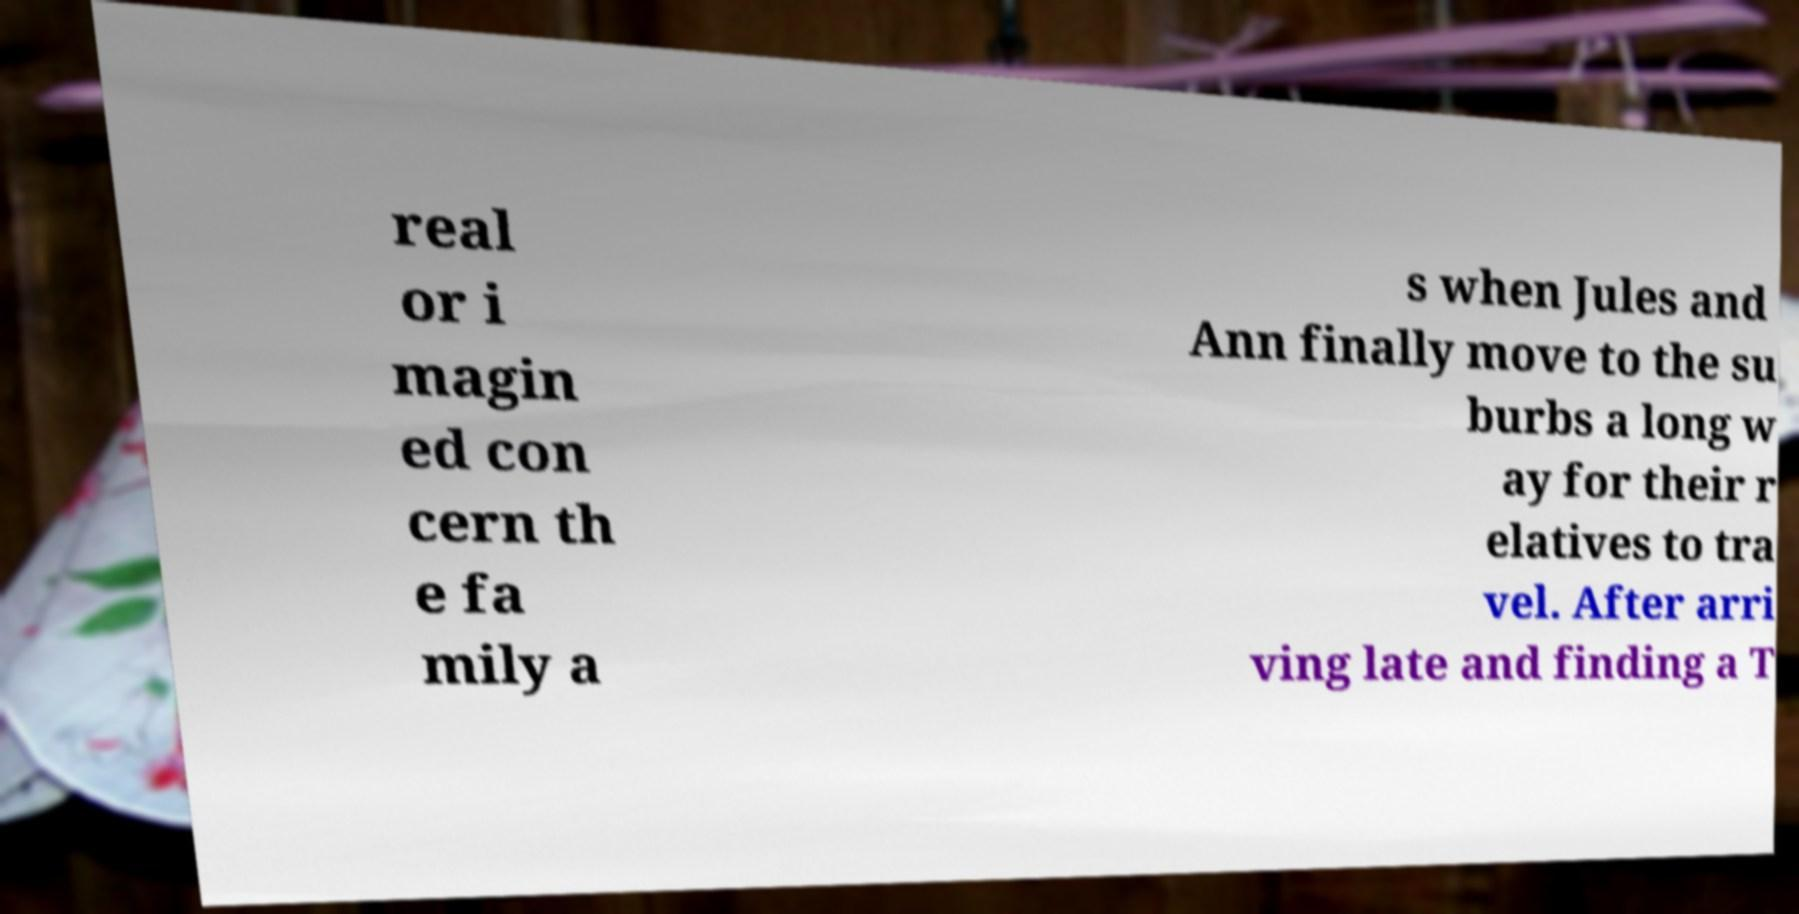Please read and relay the text visible in this image. What does it say? real or i magin ed con cern th e fa mily a s when Jules and Ann finally move to the su burbs a long w ay for their r elatives to tra vel. After arri ving late and finding a T 